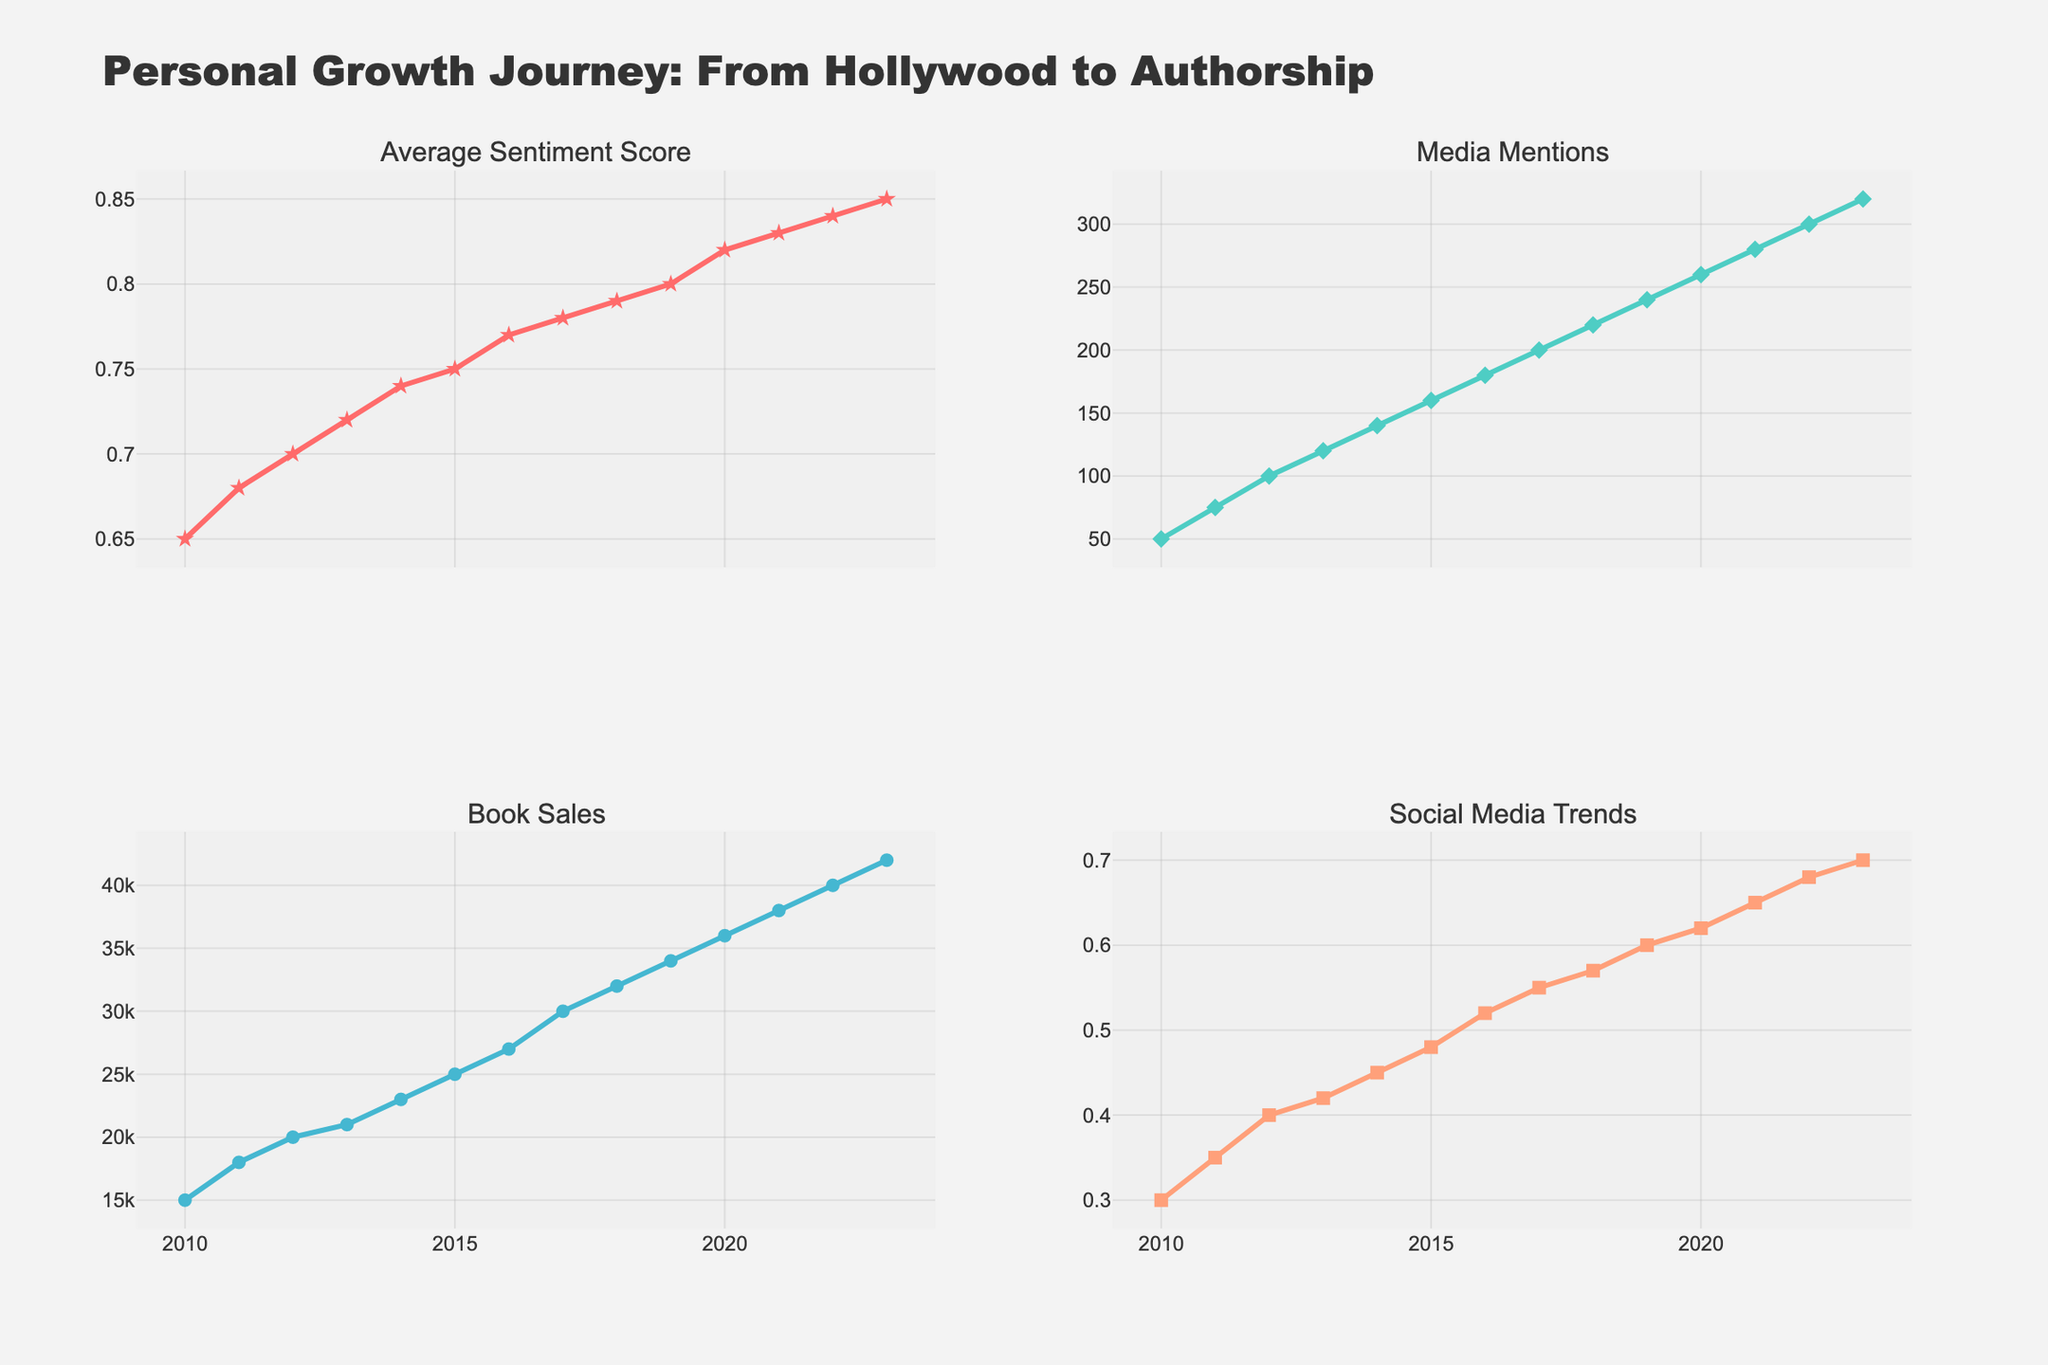What is the title of the figure? The title of the figure is prominently displayed at the top of the chart, providing an immediate understanding of the overall theme. The title is: "Personal Growth Journey: From Hollywood to Authorship".
Answer: Personal Growth Journey: From Hollywood to Authorship What trend do you observe in the Average Sentiment Score from 2010 to 2023? Observing the line for 'Average Sentiment Score', it shows a consistent upward trend over the years from 2010 to 2023. This indicates an increase in public sentiment towards personal goals and achievements.
Answer: An increasing trend Between which years did the Media Mentions see the highest increase? By comparing the Media Mentions data points year-over-year, the largest increase is noticeable between 2020 and 2021. The Media Mentions increased from 260 to 280, which is a difference of 20 mentions.
Answer: Between 2020 and 2021 How does the pattern of Book Sales compare to that of Social Media Trends over the years? Both Book Sales and Social Media Trends show a similar trend, with both rising steadily over the years from 2010 to 2023. This suggests they may be correlated, reflecting a positive reception and growing influence on social media.
Answer: Both show a rising trend What are the Media Mentions and the Book Sales values for the year 2015? Looking at the Media Mentions trace for 2015, it is at 160. Similarly, for Book Sales in 2015, it is at 25,000 units.
Answer: 160 and 25,000 respectively In which year did Social Media Trends first exceed the value of 0.5? By observing the Social Media Trends values, it can be seen that they first exceed 0.5 in the year 2016, where the value is 0.52.
Answer: 2016 Can you identify any year(s) where all four metrics (Sentiment Score, Media Mentions, Book Sales, Social Media Trends) show an increase compared to the previous year? Comparing the values year-over-year for all four metrics, in every single year from 2011 to 2023, all metrics show an increase compared to the previous year.
Answer: Every year from 2011 to 2023 Calculate the average Average Sentiment Score for the years 2018 to 2023. Adding the Sentiment Scores from 2018 to 2023: 0.79, 0.8, 0.82, 0.83, 0.84, and 0.85 gives us 4.93. Dividing this sum by the number of years (6) results in an average score of 4.93/6.
Answer: 0.8217 Which metric shows the most significant overall increase from 2010 to 2023? By comparing the start and end values for each metric: Sentiment Score (0.65 to 0.85), Media Mentions (50 to 320), Book Sales (15,000 to 42,000), Social Media Trends (0.3 to 0.7), the most significant relative increase is in Media Mentions, from 50 to 320.
Answer: Media Mentions When did the Book Sales cross the 30,000 mark? By tracing the Book Sales data points, it is crossed in the year 2017, reaching 30,000 at that point.
Answer: 2017 